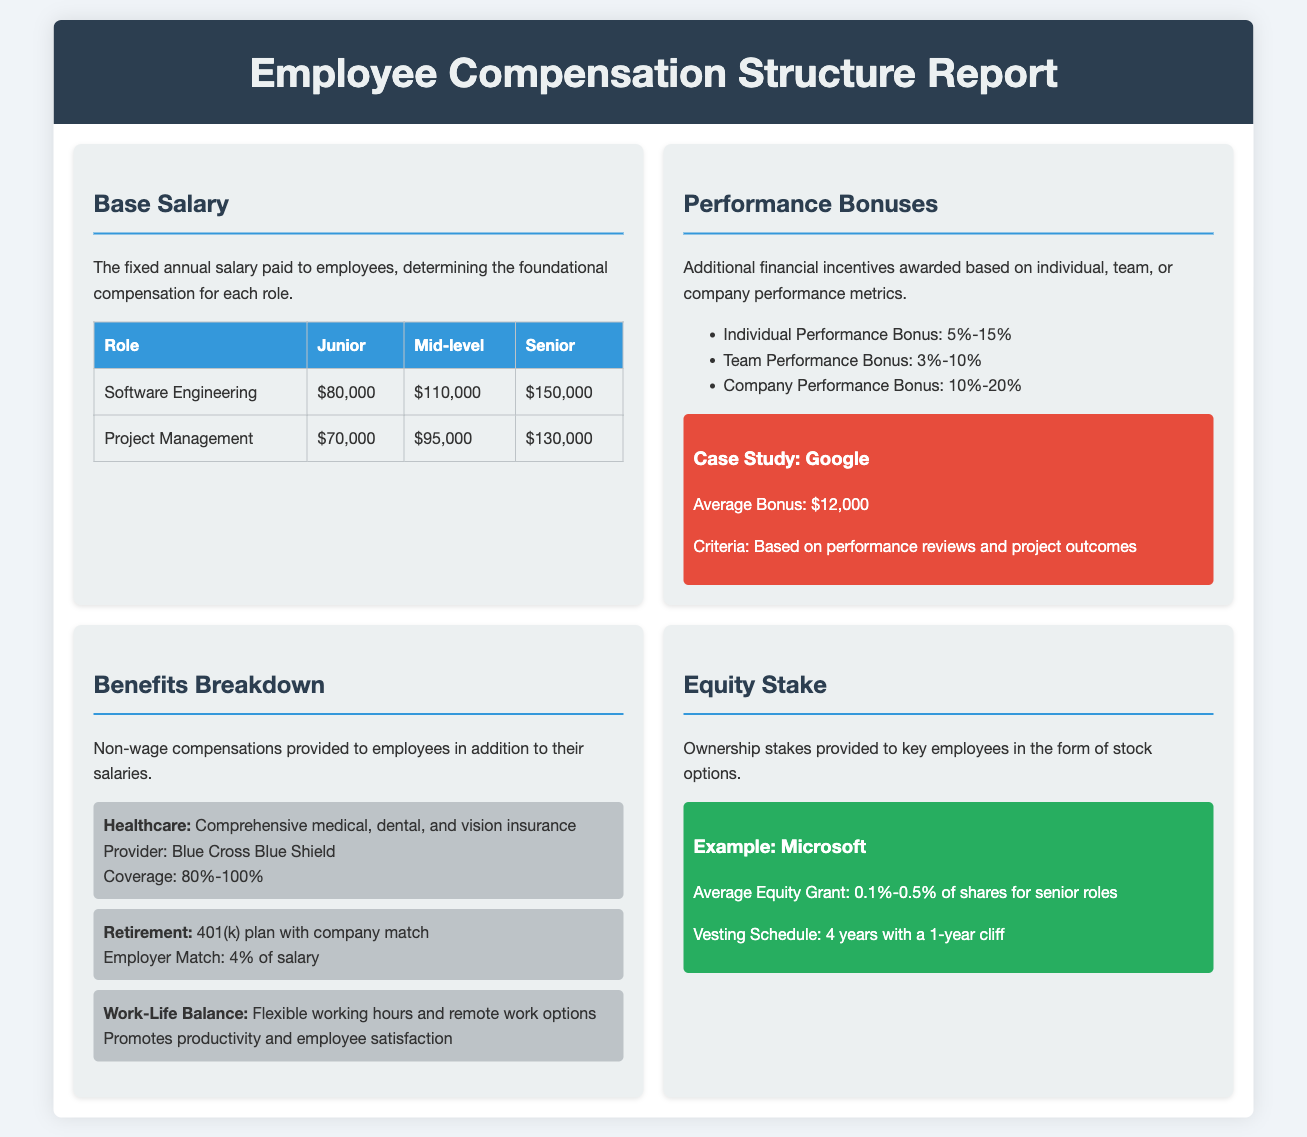what is the role and base salary for a Senior Software Engineer? The base salary for a Senior Software Engineer is stated in the document under the Base Salary section.
Answer: $150,000 what percentage is the Individual Performance Bonus? The Individual Performance Bonus percentage is detailed in the Performance Bonuses section.
Answer: 5%-15% what is the employer match percentage for the 401(k) plan? The employer match for the 401(k) plan is specified under the Benefits Breakdown section.
Answer: 4% of salary what average bonus does Google provide? The average bonus provided by Google is mentioned in the Performance Bonuses section, under the case study.
Answer: $12,000 how long is the vesting schedule for the equity grant mentioned? The duration of the vesting schedule for the equity grant is described in the Equity Stake section.
Answer: 4 years with a 1-year cliff what types of insurance are included in healthcare benefits? The specific types of insurance included in healthcare benefits are listed in the Benefits Breakdown section.
Answer: medical, dental, and vision insurance what is the coverage range for the healthcare provider stated? The coverage range for the healthcare provider is noted in the Benefits Breakdown section.
Answer: 80%-100% what is the range of the Company Performance Bonus? The Company Performance Bonus range is presented in the Performance Bonuses section.
Answer: 10%-20% 